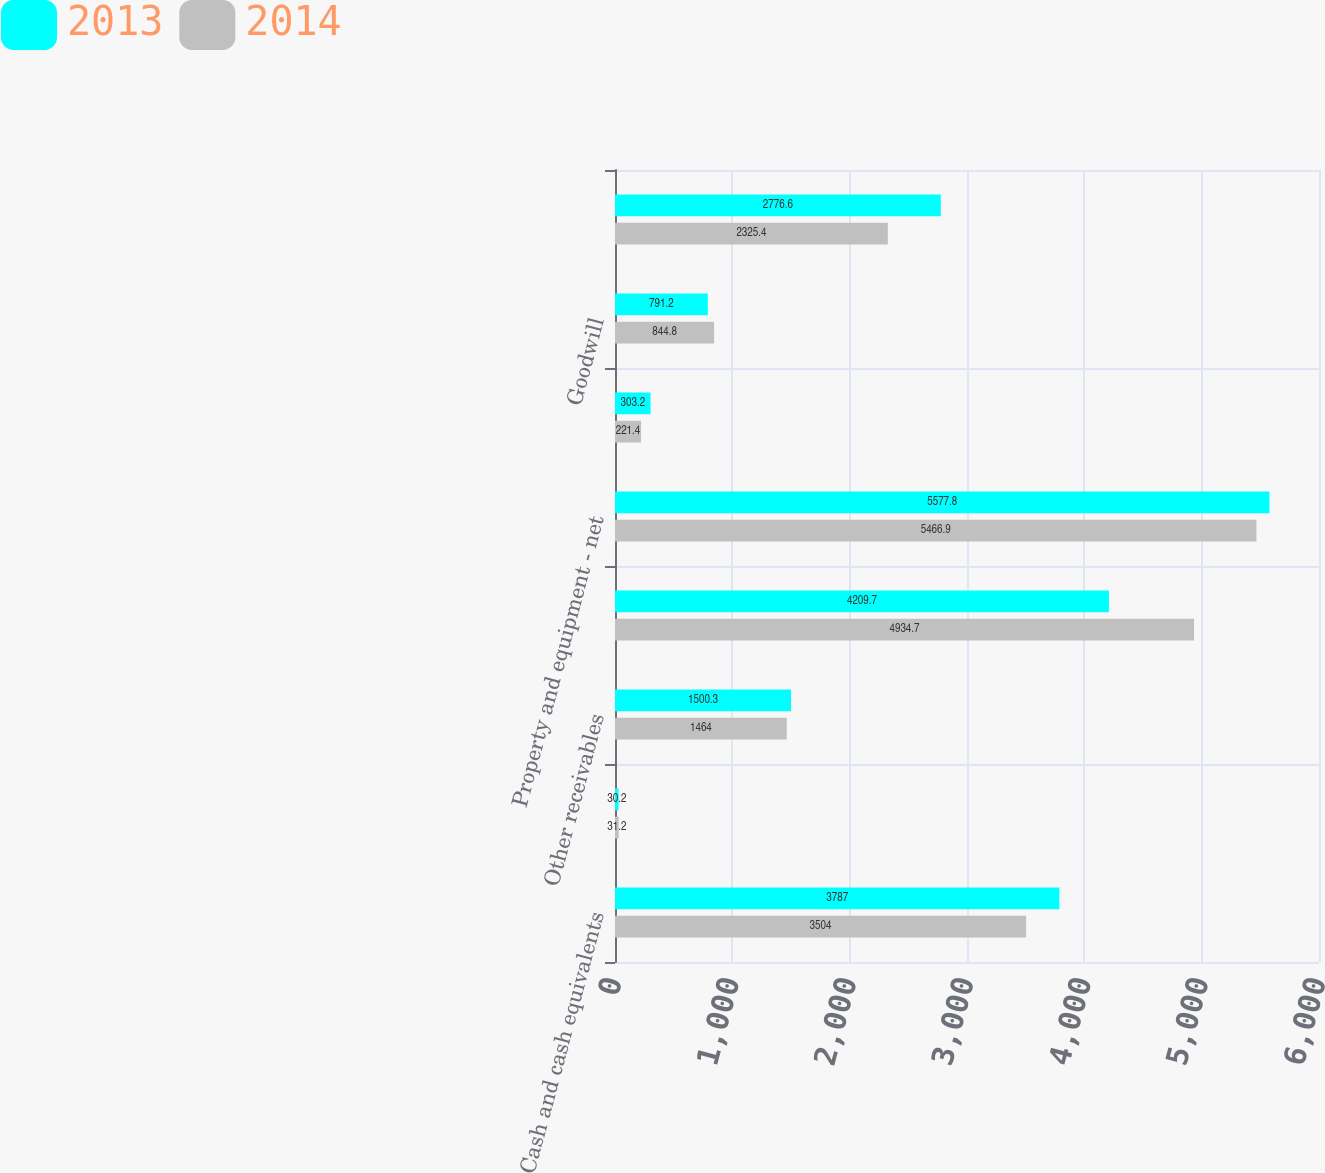Convert chart to OTSL. <chart><loc_0><loc_0><loc_500><loc_500><stacked_bar_chart><ecel><fcel>Cash and cash equivalents<fcel>Receivables from<fcel>Other receivables<fcel>Inventories<fcel>Property and equipment - net<fcel>Investments in unconsolidated<fcel>Goodwill<fcel>Deferred income taxes<nl><fcel>2013<fcel>3787<fcel>30.2<fcel>1500.3<fcel>4209.7<fcel>5577.8<fcel>303.2<fcel>791.2<fcel>2776.6<nl><fcel>2014<fcel>3504<fcel>31.2<fcel>1464<fcel>4934.7<fcel>5466.9<fcel>221.4<fcel>844.8<fcel>2325.4<nl></chart> 